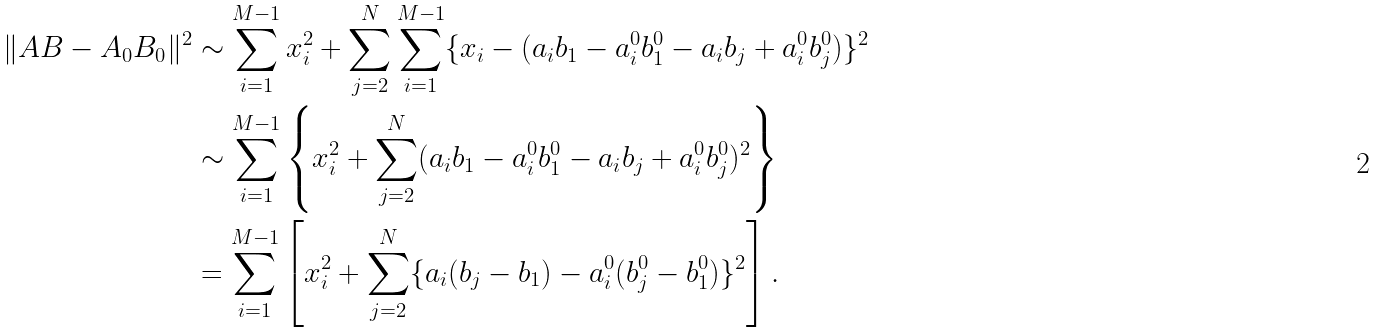<formula> <loc_0><loc_0><loc_500><loc_500>\| A B - A _ { 0 } B _ { 0 } \| ^ { 2 } & \sim \sum _ { i = 1 } ^ { M - 1 } x _ { i } ^ { 2 } + \sum _ { j = 2 } ^ { N } \sum _ { i = 1 } ^ { M - 1 } \{ x _ { i } - ( a _ { i } b _ { 1 } - a ^ { 0 } _ { i } b ^ { 0 } _ { 1 } - a _ { i } b _ { j } + a ^ { 0 } _ { i } b ^ { 0 } _ { j } ) \} ^ { 2 } \\ & \sim \sum _ { i = 1 } ^ { M - 1 } \left \{ x _ { i } ^ { 2 } + \sum _ { j = 2 } ^ { N } ( a _ { i } b _ { 1 } - a ^ { 0 } _ { i } b ^ { 0 } _ { 1 } - a _ { i } b _ { j } + a ^ { 0 } _ { i } b ^ { 0 } _ { j } ) ^ { 2 } \right \} \\ & = \sum _ { i = 1 } ^ { M - 1 } \left [ x _ { i } ^ { 2 } + \sum _ { j = 2 } ^ { N } \{ a _ { i } ( b _ { j } - b _ { 1 } ) - a ^ { 0 } _ { i } ( b ^ { 0 } _ { j } - b ^ { 0 } _ { 1 } ) \} ^ { 2 } \right ] .</formula> 